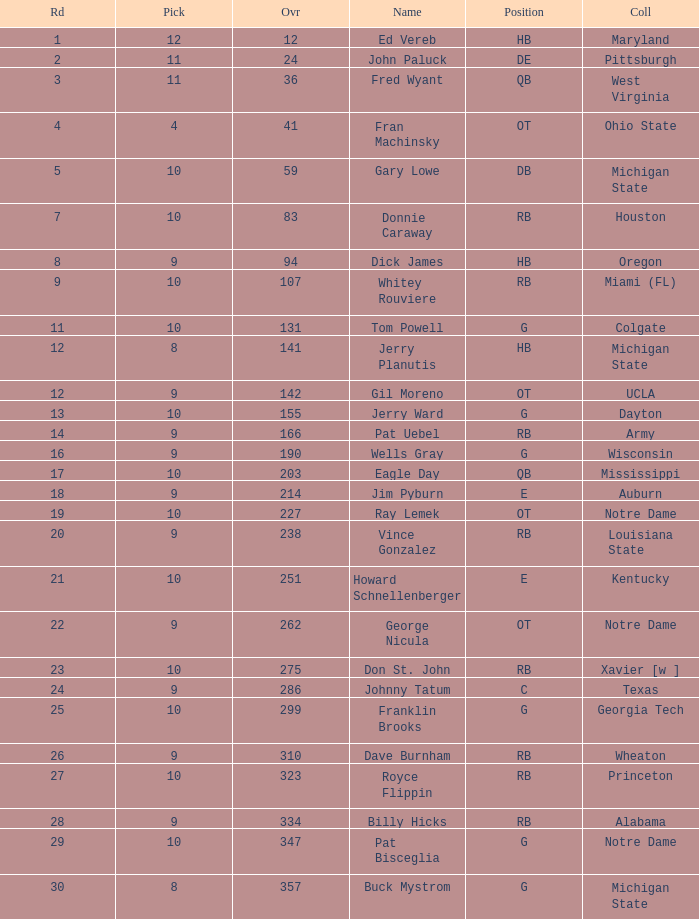Can you give me this table as a dict? {'header': ['Rd', 'Pick', 'Ovr', 'Name', 'Position', 'Coll'], 'rows': [['1', '12', '12', 'Ed Vereb', 'HB', 'Maryland'], ['2', '11', '24', 'John Paluck', 'DE', 'Pittsburgh'], ['3', '11', '36', 'Fred Wyant', 'QB', 'West Virginia'], ['4', '4', '41', 'Fran Machinsky', 'OT', 'Ohio State'], ['5', '10', '59', 'Gary Lowe', 'DB', 'Michigan State'], ['7', '10', '83', 'Donnie Caraway', 'RB', 'Houston'], ['8', '9', '94', 'Dick James', 'HB', 'Oregon'], ['9', '10', '107', 'Whitey Rouviere', 'RB', 'Miami (FL)'], ['11', '10', '131', 'Tom Powell', 'G', 'Colgate'], ['12', '8', '141', 'Jerry Planutis', 'HB', 'Michigan State'], ['12', '9', '142', 'Gil Moreno', 'OT', 'UCLA'], ['13', '10', '155', 'Jerry Ward', 'G', 'Dayton'], ['14', '9', '166', 'Pat Uebel', 'RB', 'Army'], ['16', '9', '190', 'Wells Gray', 'G', 'Wisconsin'], ['17', '10', '203', 'Eagle Day', 'QB', 'Mississippi'], ['18', '9', '214', 'Jim Pyburn', 'E', 'Auburn'], ['19', '10', '227', 'Ray Lemek', 'OT', 'Notre Dame'], ['20', '9', '238', 'Vince Gonzalez', 'RB', 'Louisiana State'], ['21', '10', '251', 'Howard Schnellenberger', 'E', 'Kentucky'], ['22', '9', '262', 'George Nicula', 'OT', 'Notre Dame'], ['23', '10', '275', 'Don St. John', 'RB', 'Xavier [w ]'], ['24', '9', '286', 'Johnny Tatum', 'C', 'Texas'], ['25', '10', '299', 'Franklin Brooks', 'G', 'Georgia Tech'], ['26', '9', '310', 'Dave Burnham', 'RB', 'Wheaton'], ['27', '10', '323', 'Royce Flippin', 'RB', 'Princeton'], ['28', '9', '334', 'Billy Hicks', 'RB', 'Alabama'], ['29', '10', '347', 'Pat Bisceglia', 'G', 'Notre Dame'], ['30', '8', '357', 'Buck Mystrom', 'G', 'Michigan State']]} What is the highest round number for donnie caraway? 7.0. 